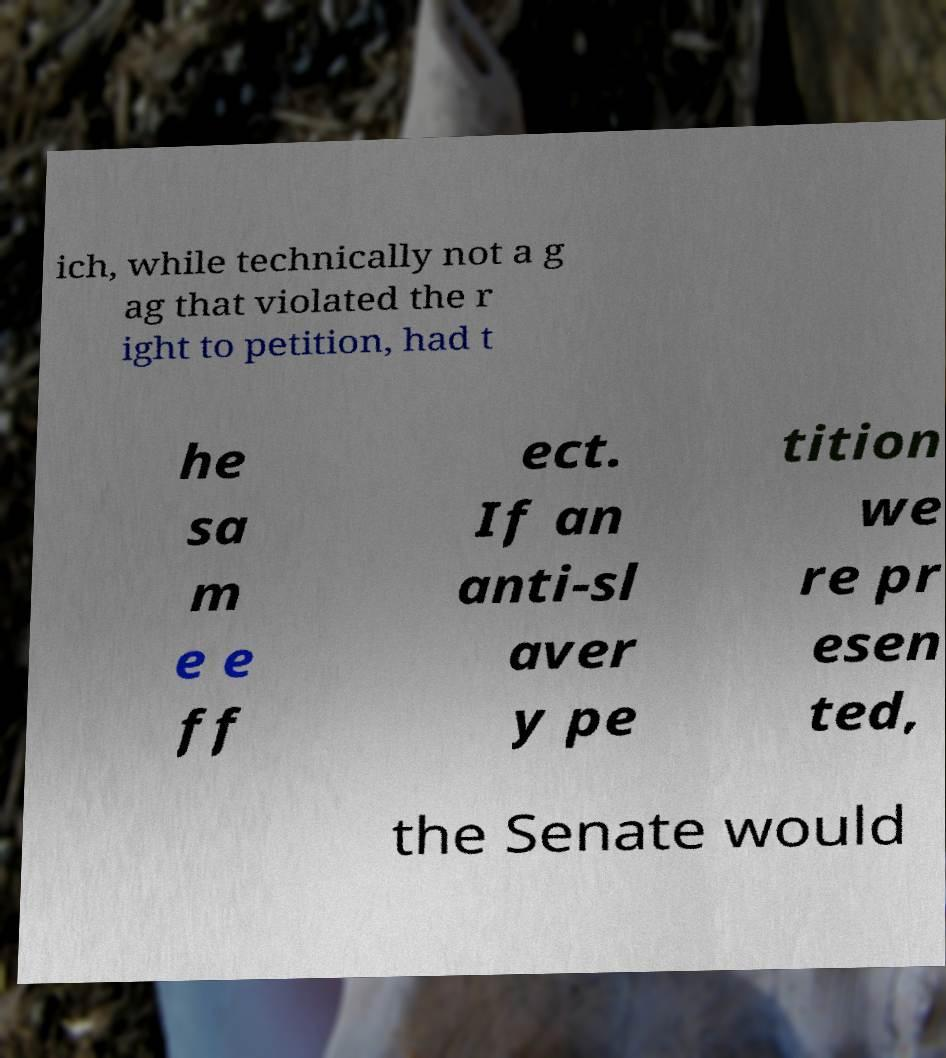Please read and relay the text visible in this image. What does it say? ich, while technically not a g ag that violated the r ight to petition, had t he sa m e e ff ect. If an anti-sl aver y pe tition we re pr esen ted, the Senate would 